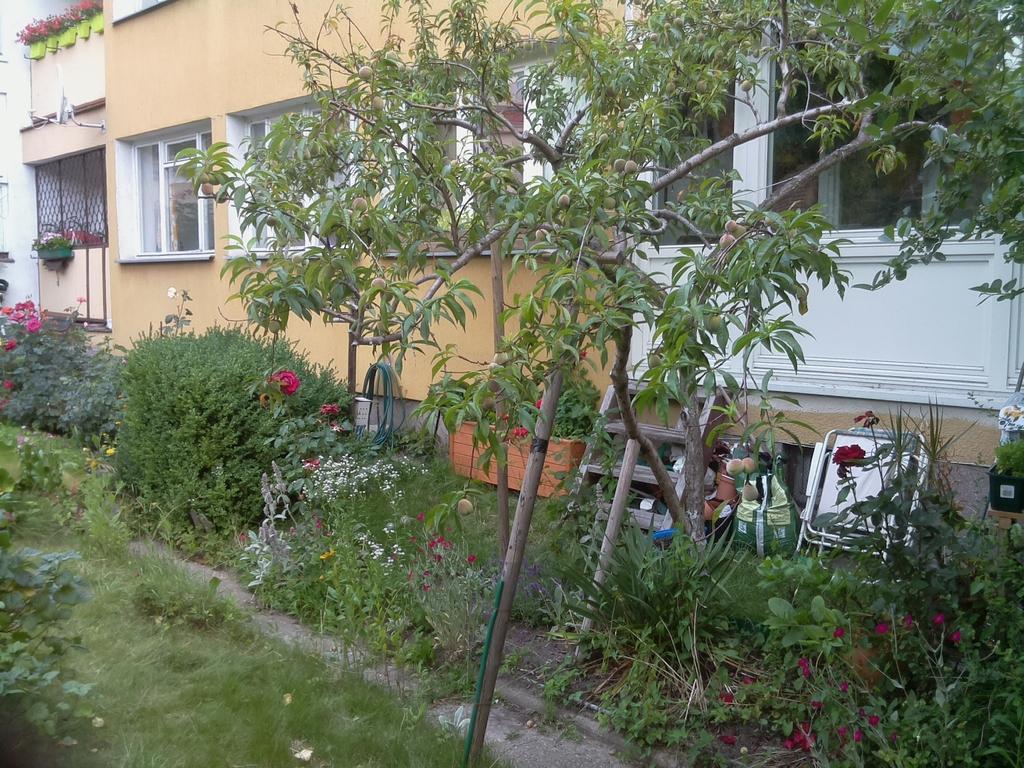How would you summarize this image in a sentence or two? This is grass. Here we can see plants, flowers, and trees. In the background we can see a building and windows. 